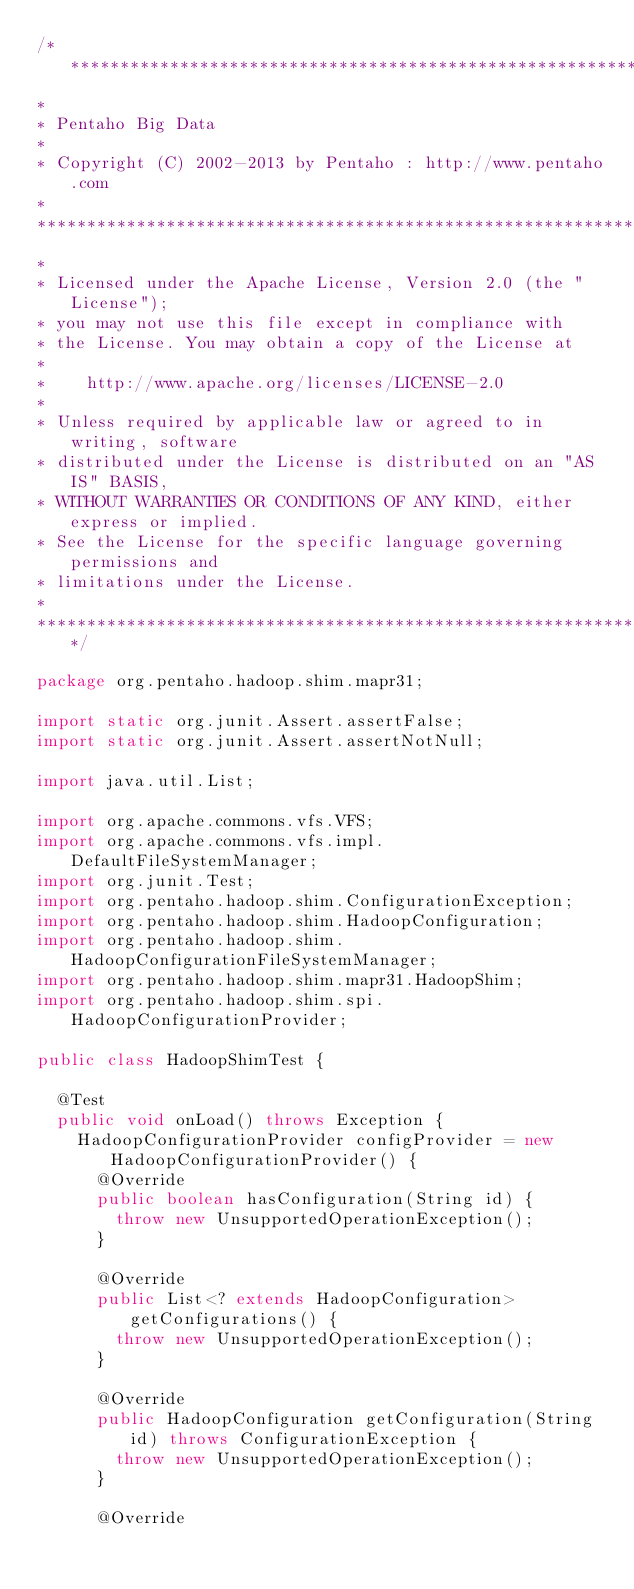Convert code to text. <code><loc_0><loc_0><loc_500><loc_500><_Java_>/*******************************************************************************
*
* Pentaho Big Data
*
* Copyright (C) 2002-2013 by Pentaho : http://www.pentaho.com
*
*******************************************************************************
*
* Licensed under the Apache License, Version 2.0 (the "License");
* you may not use this file except in compliance with
* the License. You may obtain a copy of the License at
*
*    http://www.apache.org/licenses/LICENSE-2.0
*
* Unless required by applicable law or agreed to in writing, software
* distributed under the License is distributed on an "AS IS" BASIS,
* WITHOUT WARRANTIES OR CONDITIONS OF ANY KIND, either express or implied.
* See the License for the specific language governing permissions and
* limitations under the License.
*
******************************************************************************/

package org.pentaho.hadoop.shim.mapr31;

import static org.junit.Assert.assertFalse;
import static org.junit.Assert.assertNotNull;

import java.util.List;

import org.apache.commons.vfs.VFS;
import org.apache.commons.vfs.impl.DefaultFileSystemManager;
import org.junit.Test;
import org.pentaho.hadoop.shim.ConfigurationException;
import org.pentaho.hadoop.shim.HadoopConfiguration;
import org.pentaho.hadoop.shim.HadoopConfigurationFileSystemManager;
import org.pentaho.hadoop.shim.mapr31.HadoopShim;
import org.pentaho.hadoop.shim.spi.HadoopConfigurationProvider;

public class HadoopShimTest {

  @Test
  public void onLoad() throws Exception {
    HadoopConfigurationProvider configProvider = new HadoopConfigurationProvider() {
      @Override
      public boolean hasConfiguration(String id) {
        throw new UnsupportedOperationException();
      }
      
      @Override
      public List<? extends HadoopConfiguration> getConfigurations() {
        throw new UnsupportedOperationException();
      }
      
      @Override
      public HadoopConfiguration getConfiguration(String id) throws ConfigurationException {
        throw new UnsupportedOperationException();
      }
      
      @Override</code> 